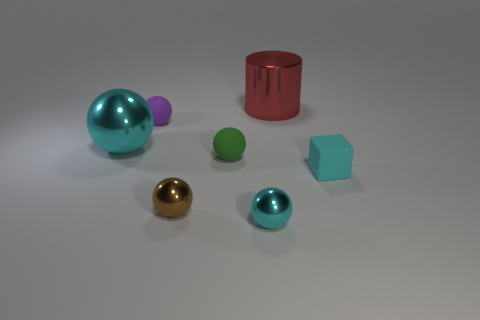What is the material of the cyan object that is on the right side of the brown metal ball and on the left side of the large red metal thing?
Give a very brief answer. Metal. There is a large red object; is its shape the same as the large metal object that is on the left side of the purple matte object?
Offer a terse response. No. What material is the small green sphere left of the small cyan thing behind the cyan shiny thing that is in front of the tiny cyan matte object made of?
Provide a succinct answer. Rubber. What number of other objects are there of the same size as the green sphere?
Keep it short and to the point. 4. Does the metallic cylinder have the same color as the small matte cube?
Make the answer very short. No. How many small rubber objects are behind the small cyan object that is behind the cyan thing in front of the cyan block?
Provide a short and direct response. 2. There is a cyan sphere that is left of the small brown thing that is in front of the cylinder; what is it made of?
Your answer should be compact. Metal. Is there a small purple matte thing of the same shape as the green object?
Your answer should be very brief. Yes. The shiny thing that is the same size as the brown ball is what color?
Offer a very short reply. Cyan. How many objects are small things on the left side of the tiny green rubber ball or cyan things that are in front of the matte cube?
Keep it short and to the point. 3. 